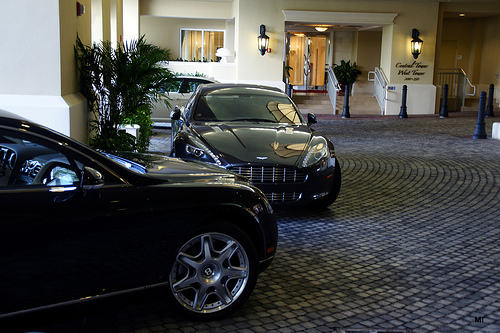<image>
Is there a car in front of the car? Yes. The car is positioned in front of the car, appearing closer to the camera viewpoint. 